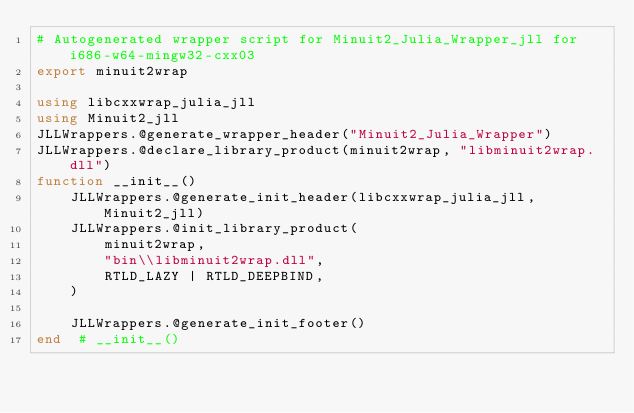Convert code to text. <code><loc_0><loc_0><loc_500><loc_500><_Julia_># Autogenerated wrapper script for Minuit2_Julia_Wrapper_jll for i686-w64-mingw32-cxx03
export minuit2wrap

using libcxxwrap_julia_jll
using Minuit2_jll
JLLWrappers.@generate_wrapper_header("Minuit2_Julia_Wrapper")
JLLWrappers.@declare_library_product(minuit2wrap, "libminuit2wrap.dll")
function __init__()
    JLLWrappers.@generate_init_header(libcxxwrap_julia_jll, Minuit2_jll)
    JLLWrappers.@init_library_product(
        minuit2wrap,
        "bin\\libminuit2wrap.dll",
        RTLD_LAZY | RTLD_DEEPBIND,
    )

    JLLWrappers.@generate_init_footer()
end  # __init__()
</code> 